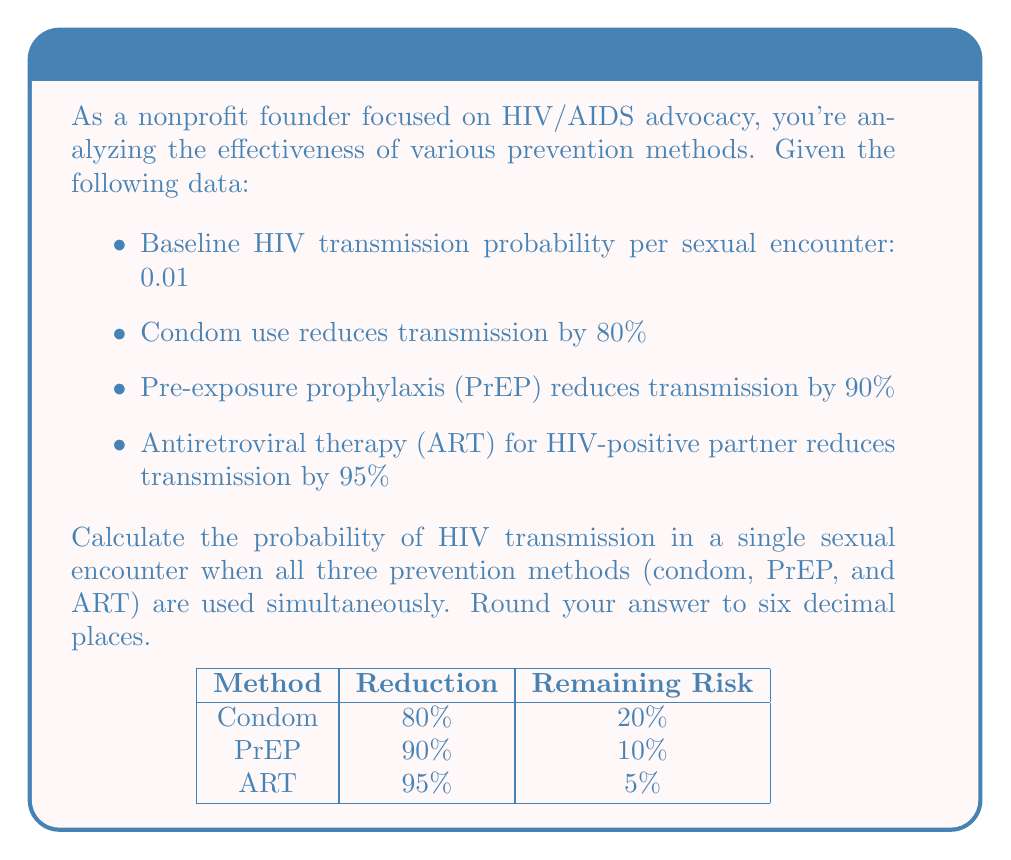Give your solution to this math problem. Let's approach this step-by-step using Bayesian probability:

1) First, let's define our baseline probability:
   $P(\text{transmission}) = 0.01$

2) Now, we need to calculate the probability of transmission given each prevention method. We can do this by multiplying the baseline probability by the complement of the reduction percentage:

   For condoms: $P(\text{transmission | condom}) = 0.01 \times (1 - 0.80) = 0.01 \times 0.20 = 0.002$
   For PrEP: $P(\text{transmission | PrEP}) = 0.01 \times (1 - 0.90) = 0.01 \times 0.10 = 0.001$
   For ART: $P(\text{transmission | ART}) = 0.01 \times (1 - 0.95) = 0.01 \times 0.05 = 0.0005$

3) When all methods are used together, we need to multiply these probabilities:

   $$\begin{align}
   P(\text{transmission | all methods}) &= P(\text{transmission | condom}) \times P(\text{transmission | PrEP}) \times P(\text{transmission | ART}) \\
   &= 0.002 \times 0.001 \times 0.0005 \\
   &= 1 \times 10^{-9}
   \end{align}$$

4) Rounding to six decimal places:
   $1 \times 10^{-9} \approx 0.000001$

Therefore, the probability of HIV transmission when all three prevention methods are used simultaneously is approximately 0.000001 or 1 in 1,000,000.
Answer: 0.000001 